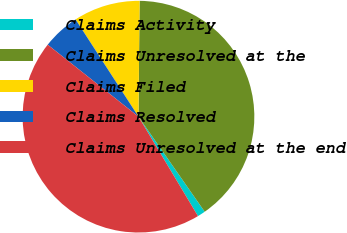<chart> <loc_0><loc_0><loc_500><loc_500><pie_chart><fcel>Claims Activity<fcel>Claims Unresolved at the<fcel>Claims Filed<fcel>Claims Resolved<fcel>Claims Unresolved at the end<nl><fcel>1.1%<fcel>40.16%<fcel>9.29%<fcel>5.19%<fcel>44.25%<nl></chart> 